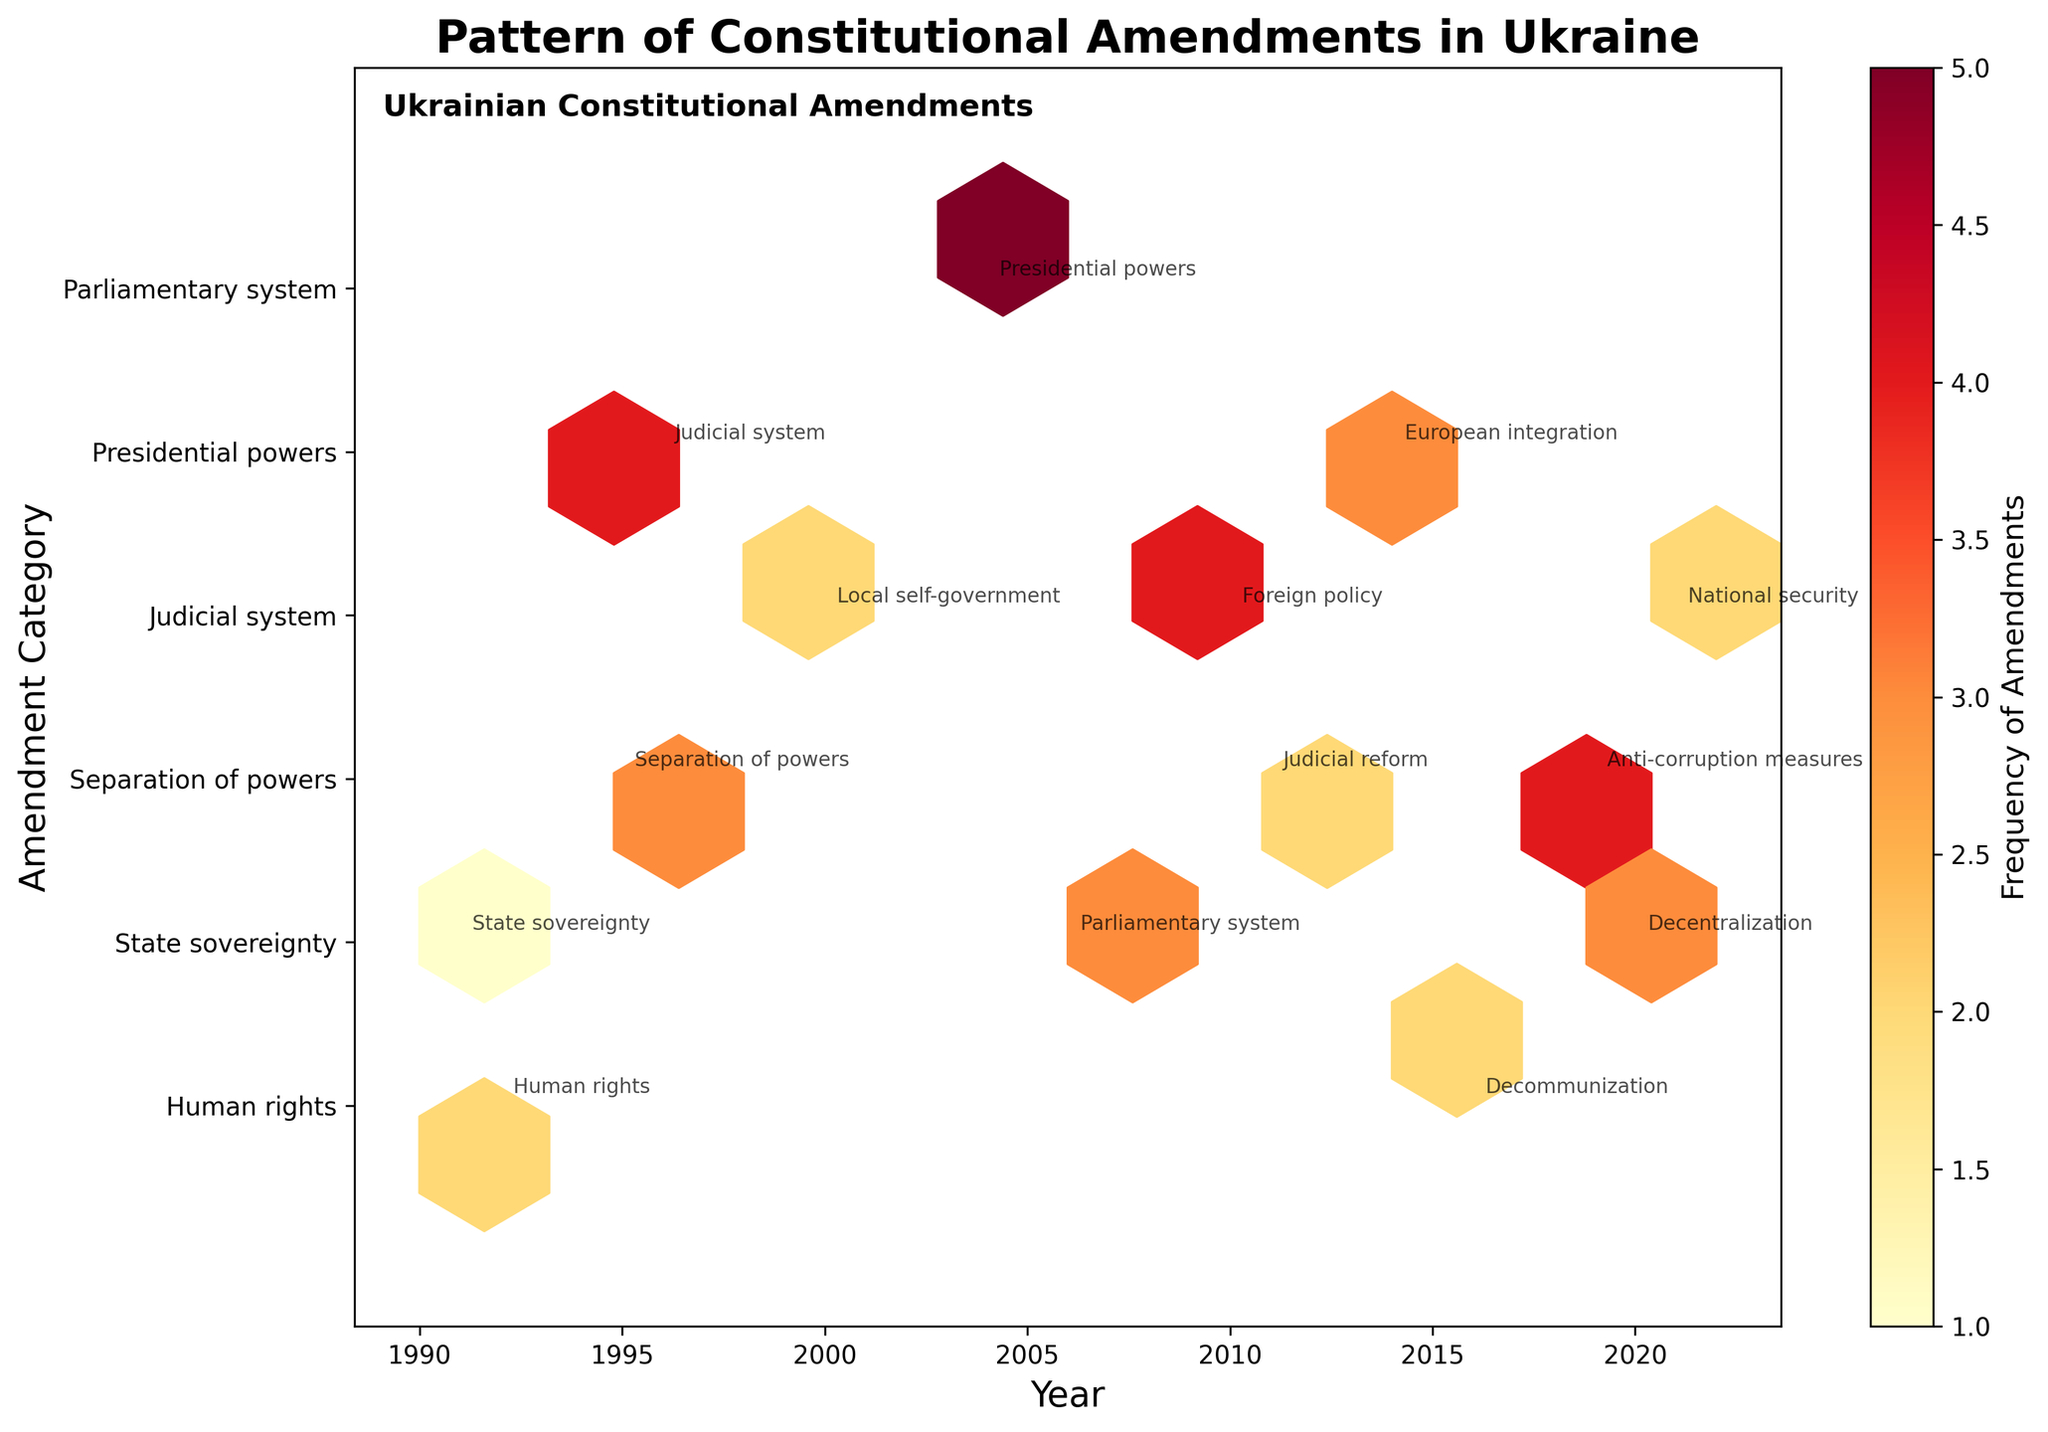What is the title of the figure? The title of the figure is displayed prominently at the top and reads "Pattern of Constitutional Amendments in Ukraine".
Answer: Pattern of Constitutional Amendments in Ukraine How many amendment categories are represented on the y-axis? The y-axis shows tick marks with labels, and there are 6 categories listed.
Answer: 6 In which year did the most frequent amendments occur according to the color intensity? The color intensity in the hexbin plot indicates the frequency of amendments, and the most intense color appears around the year 2004.
Answer: 2004 Which period (pre-2000 or post-2000) has more diverse amendment subjects based on the annotations? Observing the distribution of subject annotations, post-2000 has a more diverse range of subjects indicated by various annotations.
Answer: Post-2000 What's the general trend in constitutional amendments frequency over the years? By observing the color changes across the years from 1991 to 2021, there's a noticeable increase in frequency closer to 2004, followed by less frequent but more consistent amendments in the later years.
Answer: Increased around 2004, then consistent How many subject matters are annotated on the plot for the year 1996? Observing the annotations specifically at the year 1996, there is one subject matter noted, which is "Judicial system".
Answer: 1 What is the max frequency of amendments for the category "Presidential powers"? Look for the color intensity around the category "Presidential powers" in the y-axis, specifically around the years, and note the highest frequency shown which is 5 in 2004.
Answer: 5 Which subject matter is associated with the year 2010? The plot annotations for the year 2010 show the subject matter associated as "Foreign policy".
Answer: Foreign policy Which political climate is linked to the 2011 judicial reform? The annotation near the frequency at the year 2011 mentions the political climate, which is "Euromaidan prelude".
Answer: Euromaidan prelude Compare the frequency of amendments between "Parliamentary system" and "Judicial system" post-2000. Which one is higher? Reviewing the color intensities and annotations post-2000 for both categories, "Judicial system" has a higher relative frequency (e.g., 4 in 2010) versus "Parliamentary system" (e.g., 3 in 2006).
Answer: Judicial system 